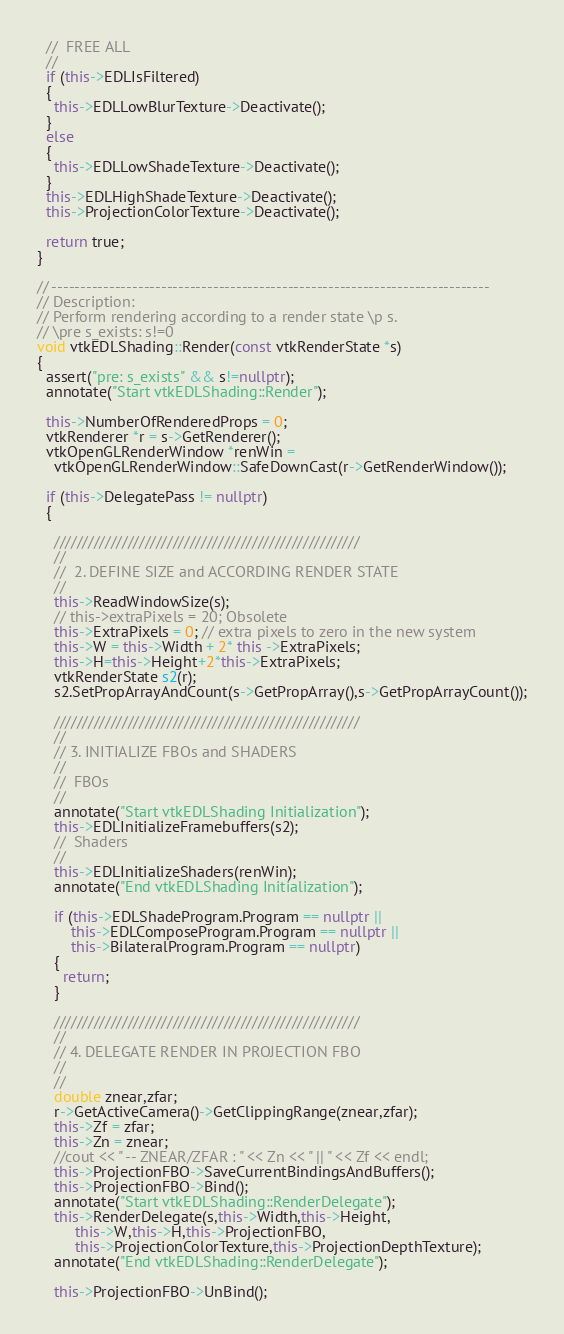<code> <loc_0><loc_0><loc_500><loc_500><_C++_>  //  FREE ALL
  //
  if (this->EDLIsFiltered)
  {
    this->EDLLowBlurTexture->Deactivate();
  }
  else
  {
    this->EDLLowShadeTexture->Deactivate();
  }
  this->EDLHighShadeTexture->Deactivate();
  this->ProjectionColorTexture->Deactivate();

  return true;
}

// ----------------------------------------------------------------------------
// Description:
// Perform rendering according to a render state \p s.
// \pre s_exists: s!=0
void vtkEDLShading::Render(const vtkRenderState *s)
{
  assert("pre: s_exists" && s!=nullptr);
  annotate("Start vtkEDLShading::Render");

  this->NumberOfRenderedProps = 0;
  vtkRenderer *r = s->GetRenderer();
  vtkOpenGLRenderWindow *renWin =
    vtkOpenGLRenderWindow::SafeDownCast(r->GetRenderWindow());

  if (this->DelegatePass != nullptr)
  {

    //////////////////////////////////////////////////////
    //
    //  2. DEFINE SIZE and ACCORDING RENDER STATE
    //
    this->ReadWindowSize(s);
    // this->extraPixels = 20; Obsolete
    this->ExtraPixels = 0; // extra pixels to zero in the new system
    this->W = this->Width + 2* this ->ExtraPixels;
    this->H=this->Height+2*this->ExtraPixels;
    vtkRenderState s2(r);
    s2.SetPropArrayAndCount(s->GetPropArray(),s->GetPropArrayCount());

    //////////////////////////////////////////////////////
    //
    // 3. INITIALIZE FBOs and SHADERS
    //
    //  FBOs
    //
    annotate("Start vtkEDLShading Initialization");
    this->EDLInitializeFramebuffers(s2);
    //  Shaders
    //
    this->EDLInitializeShaders(renWin);
    annotate("End vtkEDLShading Initialization");

    if (this->EDLShadeProgram.Program == nullptr ||
        this->EDLComposeProgram.Program == nullptr ||
        this->BilateralProgram.Program == nullptr)
    {
      return;
    }

    //////////////////////////////////////////////////////
    //
    // 4. DELEGATE RENDER IN PROJECTION FBO
    //
    //
    double znear,zfar;
    r->GetActiveCamera()->GetClippingRange(znear,zfar);
    this->Zf = zfar;
    this->Zn = znear;
    //cout << " -- ZNEAR/ZFAR : " << Zn << " || " << Zf << endl;
    this->ProjectionFBO->SaveCurrentBindingsAndBuffers();
    this->ProjectionFBO->Bind();
    annotate("Start vtkEDLShading::RenderDelegate");
    this->RenderDelegate(s,this->Width,this->Height,
         this->W,this->H,this->ProjectionFBO,
         this->ProjectionColorTexture,this->ProjectionDepthTexture);
    annotate("End vtkEDLShading::RenderDelegate");

    this->ProjectionFBO->UnBind();
</code> 